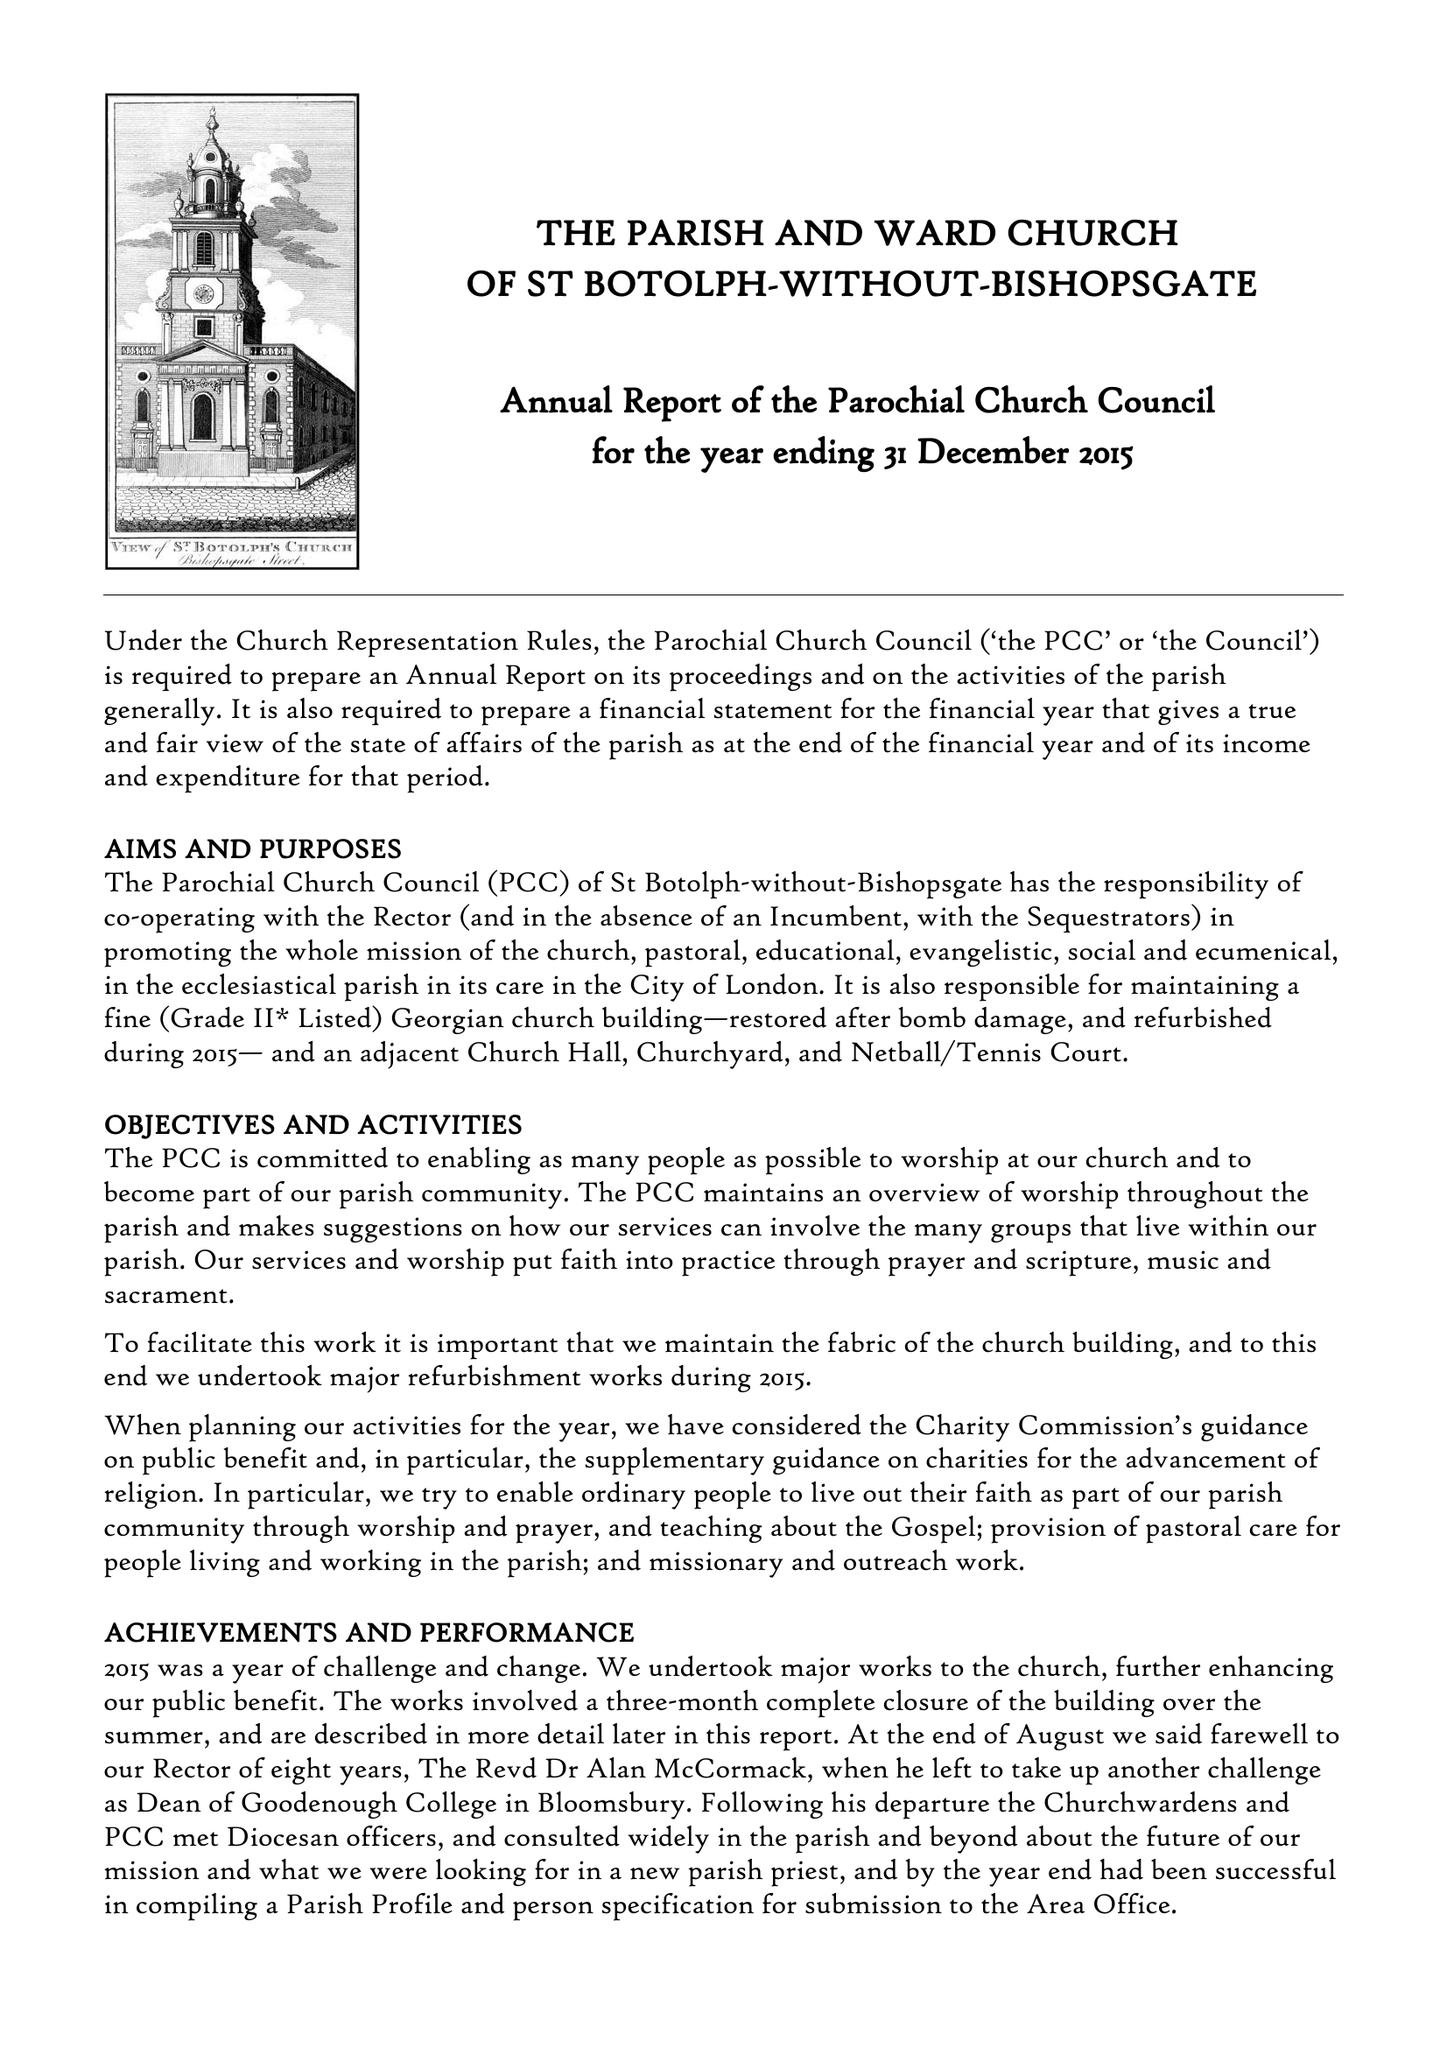What is the value for the charity_name?
Answer the question using a single word or phrase. The Parochial Church Council Of The Ecclesiastical Parish Of St Botolph-Without-Bishopsgate 